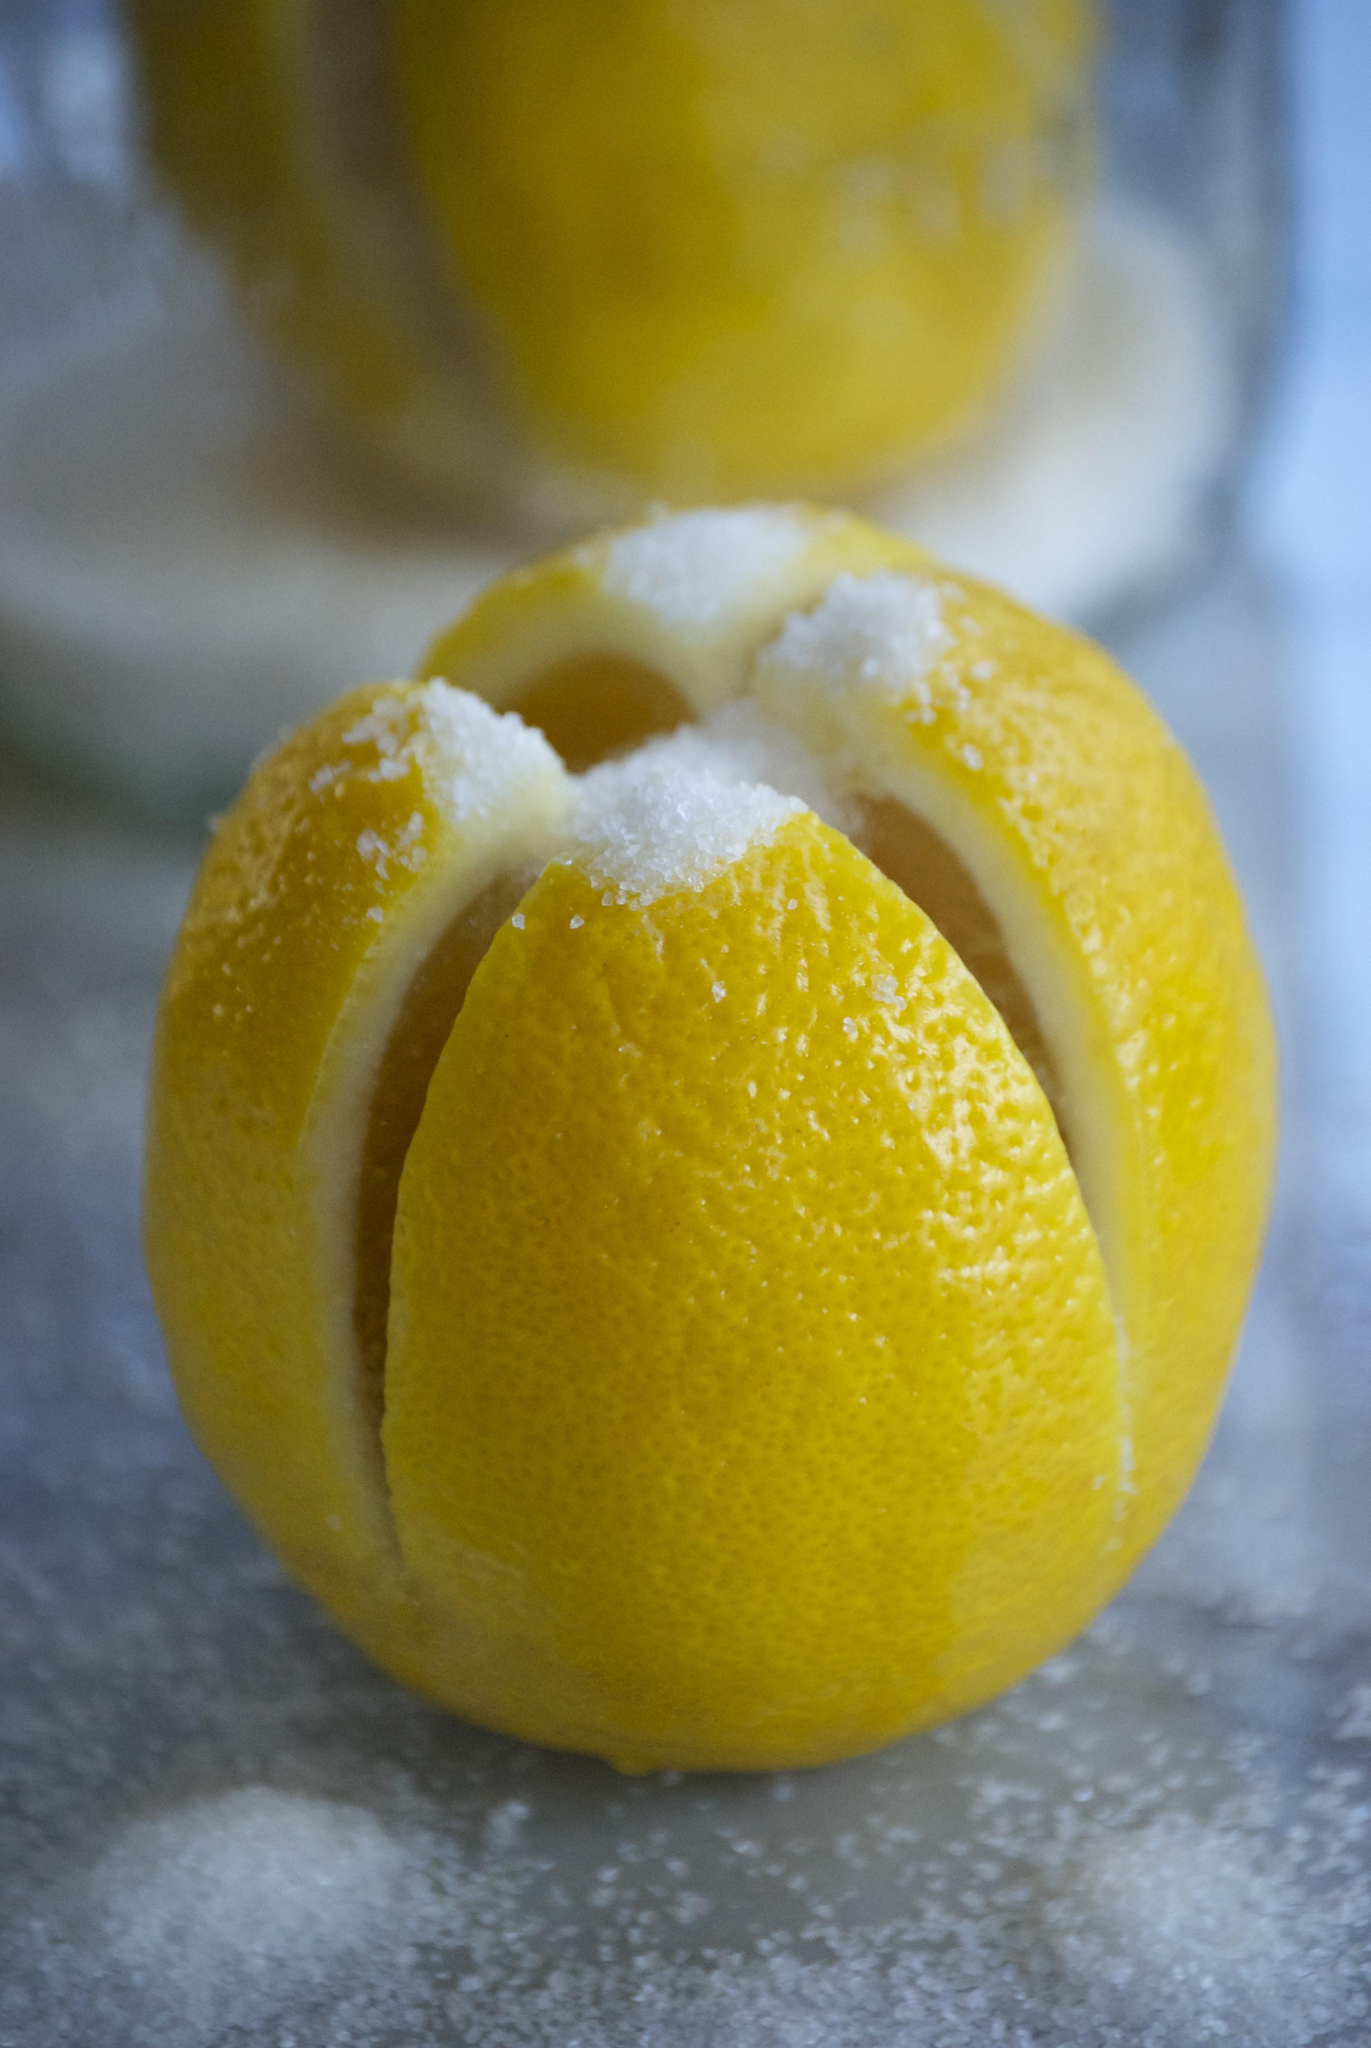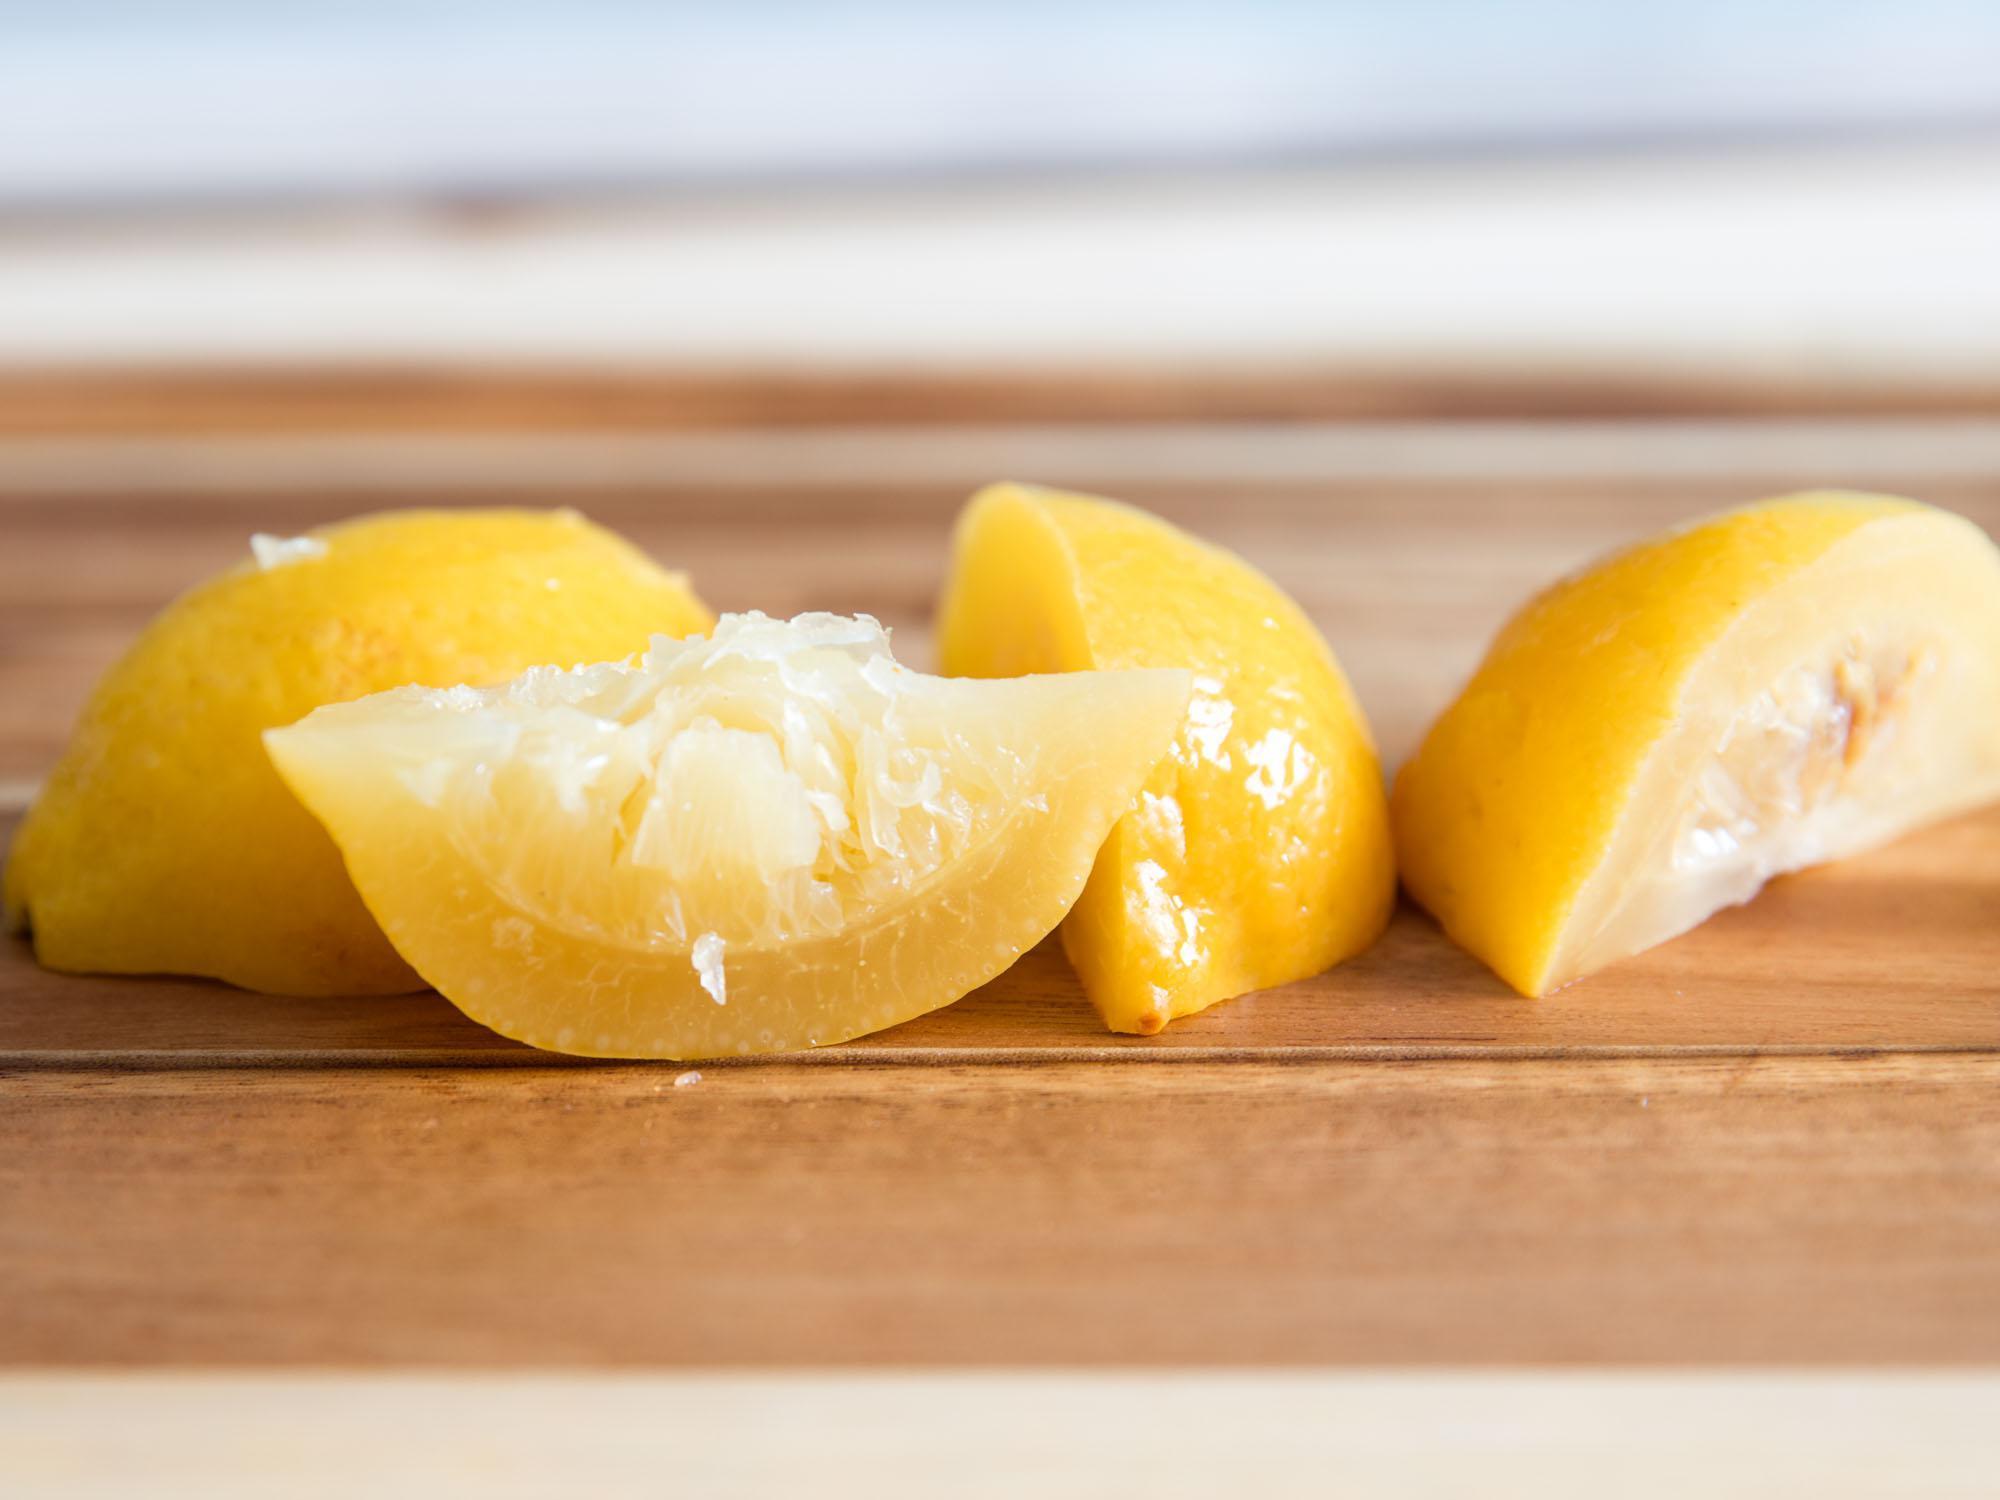The first image is the image on the left, the second image is the image on the right. Examine the images to the left and right. Is the description "In at least one image there are a total of four lemon slices." accurate? Answer yes or no. Yes. The first image is the image on the left, the second image is the image on the right. Considering the images on both sides, is "The left image contains at least one lemon with a criss-cross cut through the top filled with fine white grains." valid? Answer yes or no. Yes. 